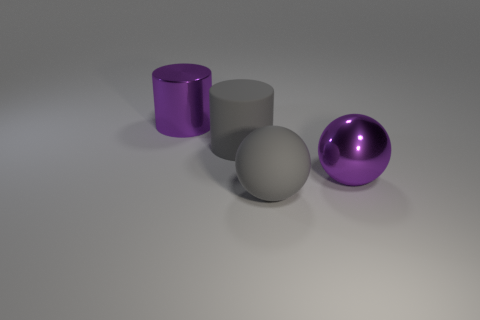What is the material of the big thing that is the same color as the metal ball?
Your answer should be compact. Metal. There is a ball that is in front of the metal thing that is in front of the purple metal object that is on the left side of the large metallic ball; what size is it?
Offer a terse response. Large. Are there any things that have the same color as the large metallic sphere?
Your response must be concise. Yes. How many spheres are big gray objects or purple objects?
Offer a very short reply. 2. What number of other things are there of the same color as the rubber cylinder?
Offer a very short reply. 1. Is the number of large matte spheres on the right side of the shiny ball less than the number of purple objects?
Your answer should be compact. Yes. How many big purple metal balls are there?
Keep it short and to the point. 1. What number of purple things are made of the same material as the large purple ball?
Your response must be concise. 1. What number of objects are either shiny objects that are in front of the purple cylinder or cylinders?
Provide a succinct answer. 3. Are there fewer large metal spheres to the right of the gray matte cylinder than big rubber things behind the shiny sphere?
Keep it short and to the point. No. 